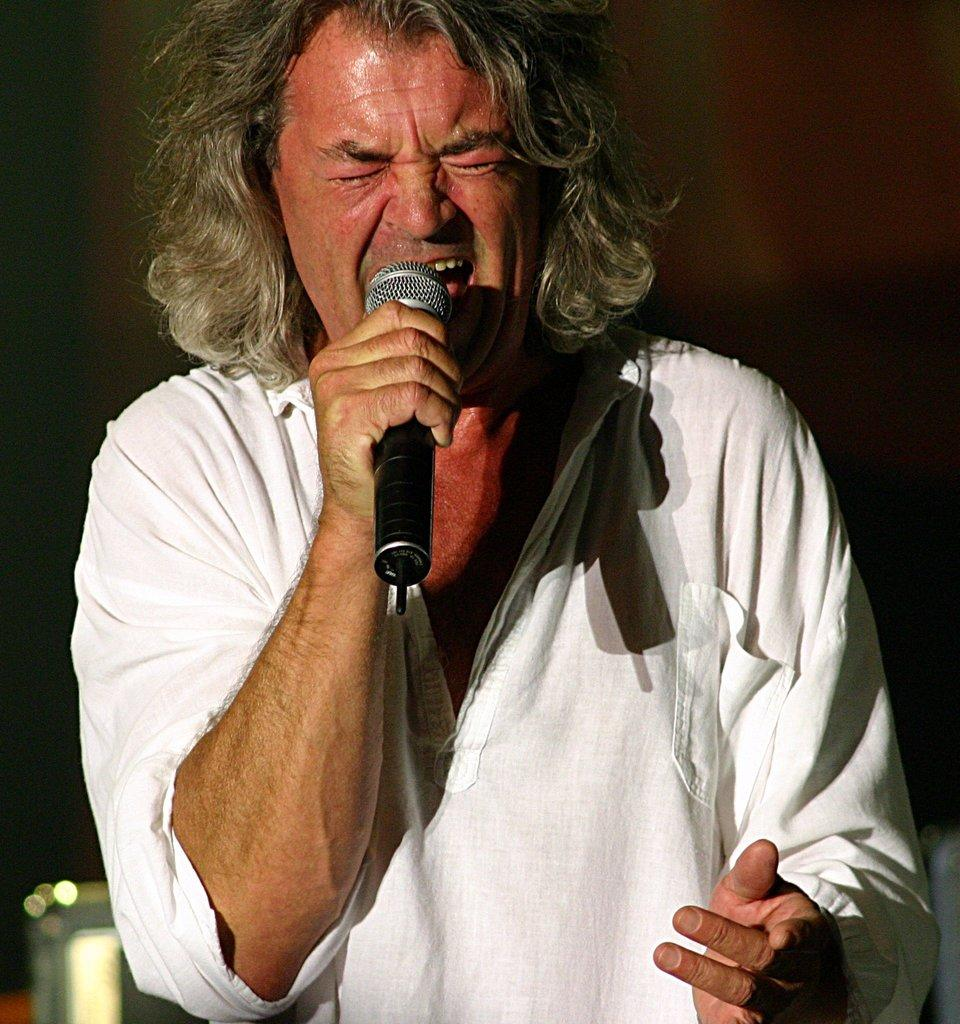What is the main subject in the foreground of the picture? There is a person in the foreground of the picture. What is the person holding in the image? The person is holding a mic. What is the person doing with the mic? The person is singing. What can be observed about the background of the image? The background of the image is dark. What type of quince can be seen in the image? There is no quince present in the image. How many bubbles are floating around the person in the image? There are no bubbles present in the image. 